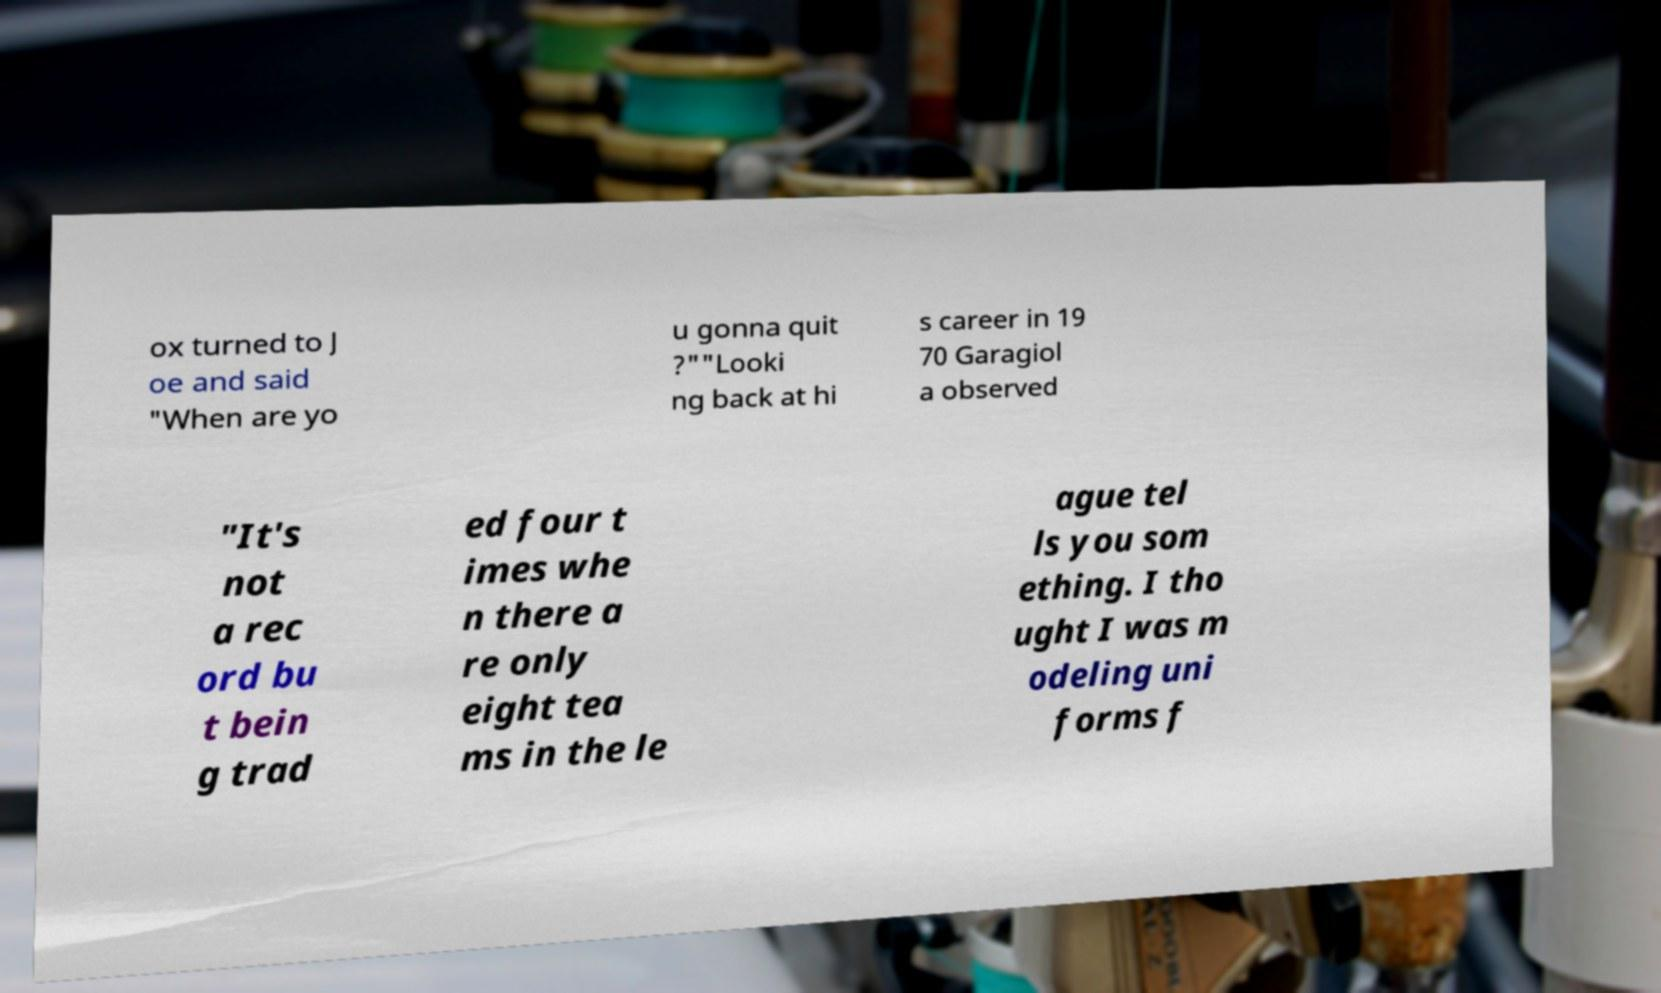Could you extract and type out the text from this image? ox turned to J oe and said "When are yo u gonna quit ?""Looki ng back at hi s career in 19 70 Garagiol a observed "It's not a rec ord bu t bein g trad ed four t imes whe n there a re only eight tea ms in the le ague tel ls you som ething. I tho ught I was m odeling uni forms f 